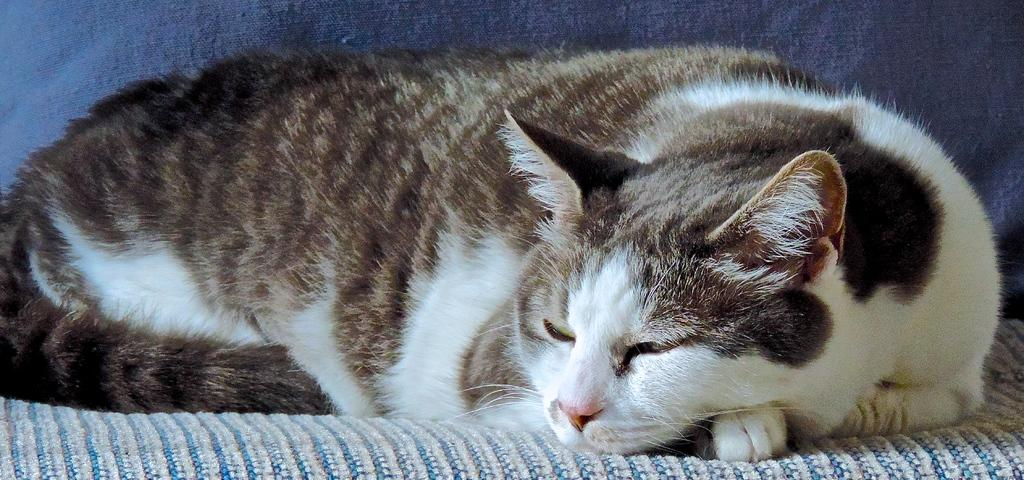What type of picture is shown in the image? The image is a zoomed in picture. What can be seen in the zoomed in picture? There is a cat in the image. Where is the cat located? The cat is present on a sofa. What type of learning is the cat engaged in while sitting on the sofa? The image does not show the cat engaged in any learning activity; it simply shows the cat sitting on a sofa. How many frogs are present on the sofa with the cat? There are no frogs present in the image; it only shows a cat on a sofa. 